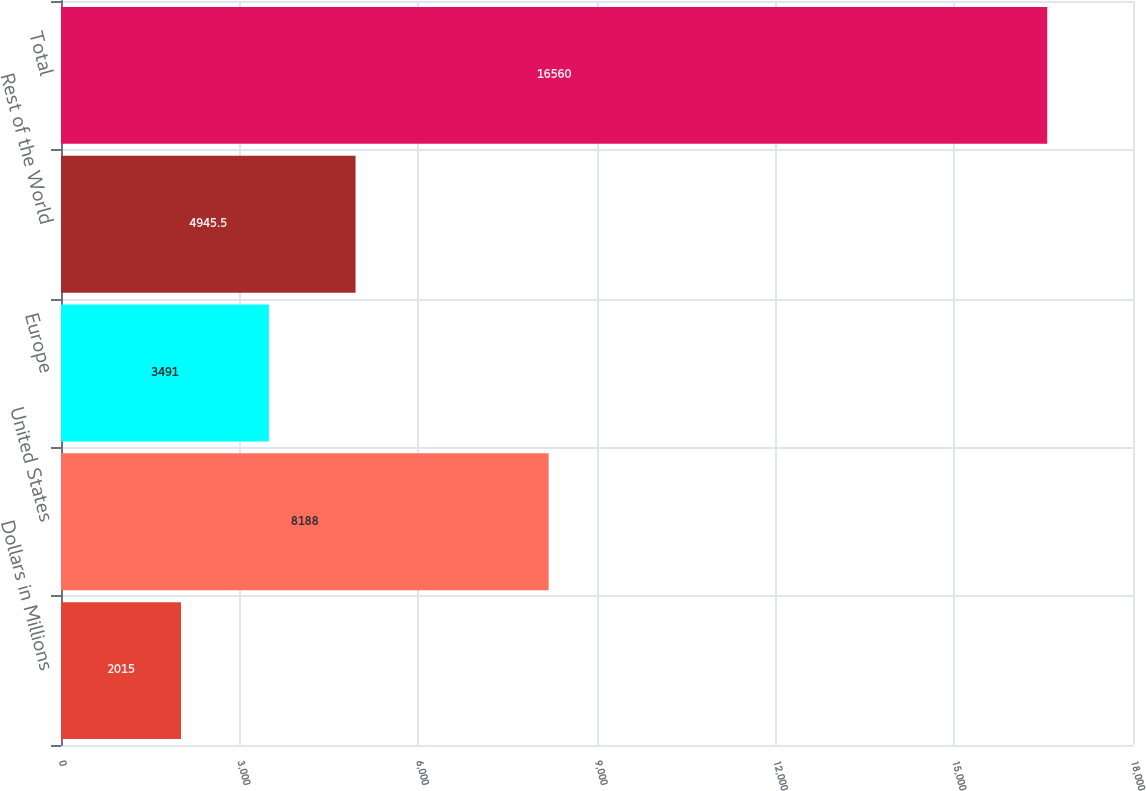<chart> <loc_0><loc_0><loc_500><loc_500><bar_chart><fcel>Dollars in Millions<fcel>United States<fcel>Europe<fcel>Rest of the World<fcel>Total<nl><fcel>2015<fcel>8188<fcel>3491<fcel>4945.5<fcel>16560<nl></chart> 